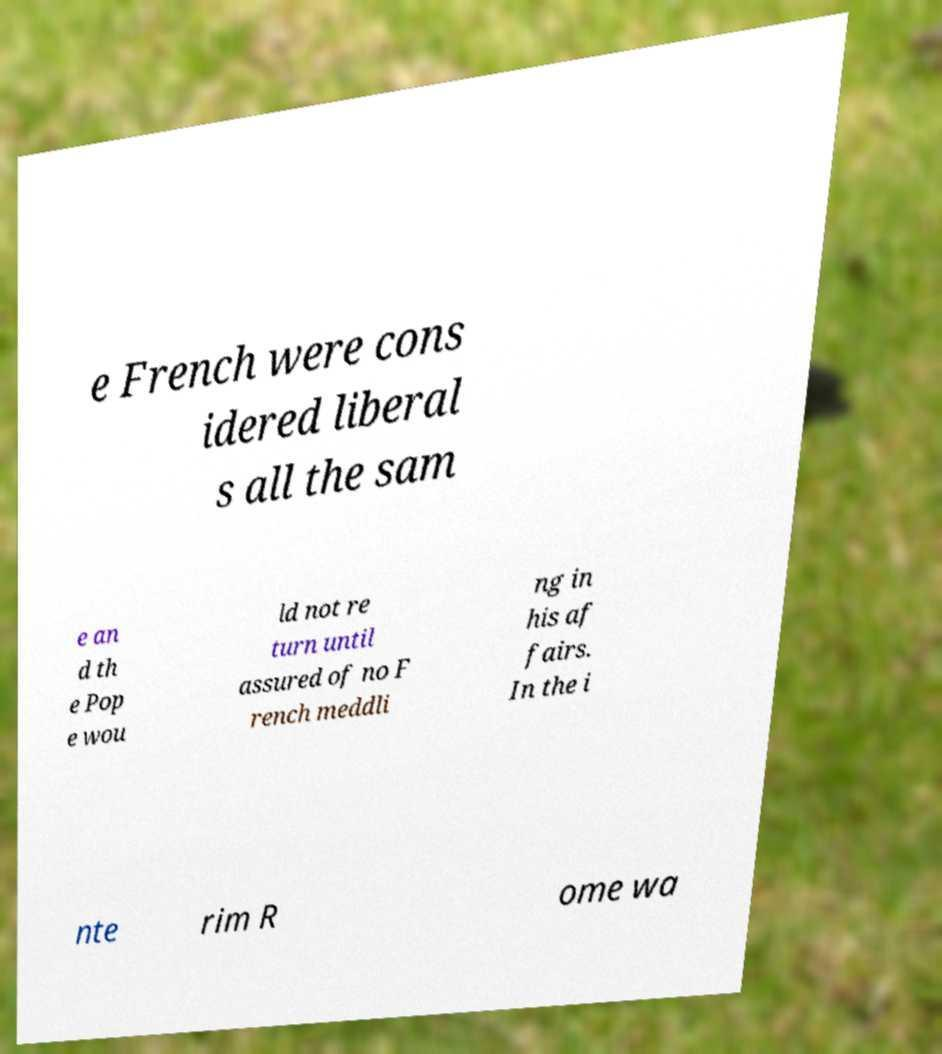There's text embedded in this image that I need extracted. Can you transcribe it verbatim? e French were cons idered liberal s all the sam e an d th e Pop e wou ld not re turn until assured of no F rench meddli ng in his af fairs. In the i nte rim R ome wa 